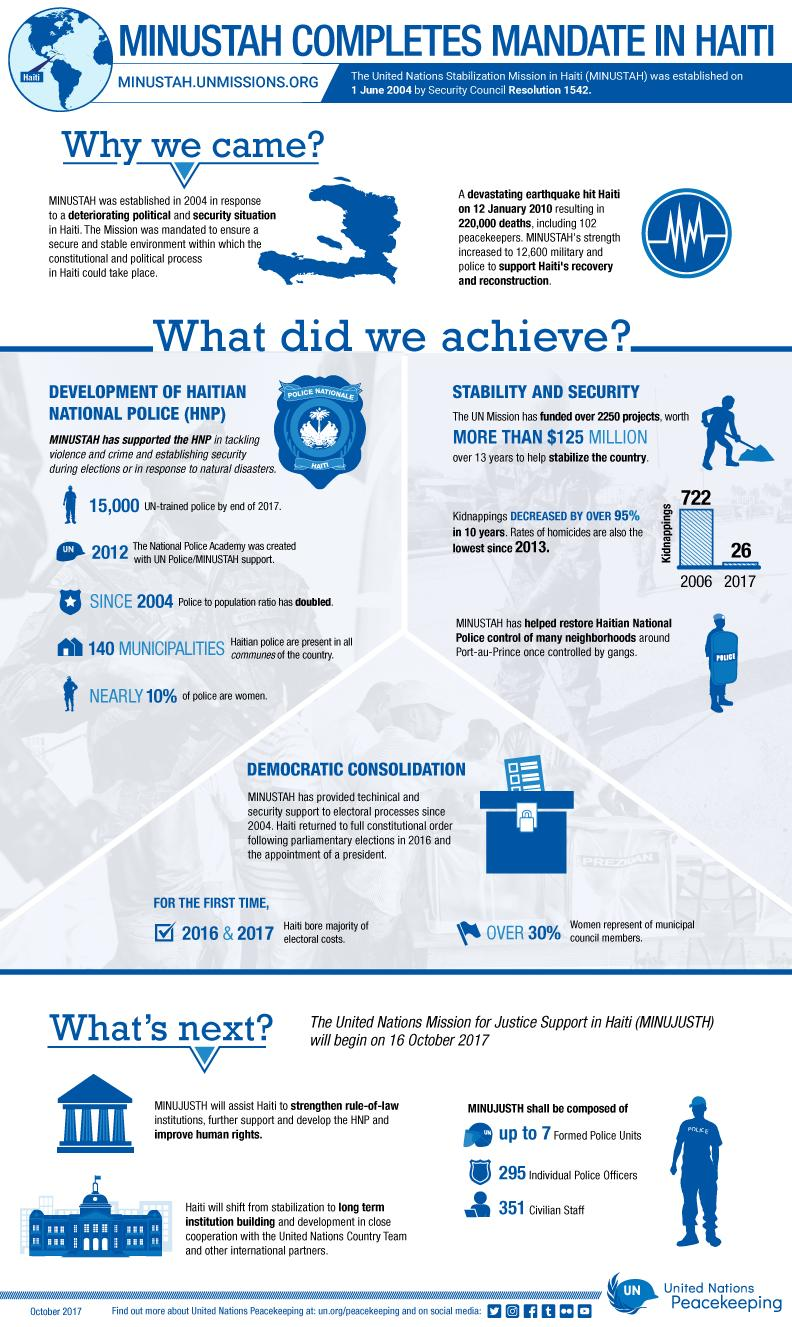List a handful of essential elements in this visual. The United Nations Mission for Justice Support in Haiti (MINUJUSTH) will help to improve human rights in Haiti. Haiti was hit by a devastating earthquake in 2010. In the earthquake, approximately 220,000 people lost their lives. It is reported that 102 peacekeepers perished in the earthquake. The strength of the United Nations Stabilization Mission in Haiti (MINUSTAH) was increased in 2010 to support Haiti's recovery and reconstruction following the devastating earthquake that struck the country. 